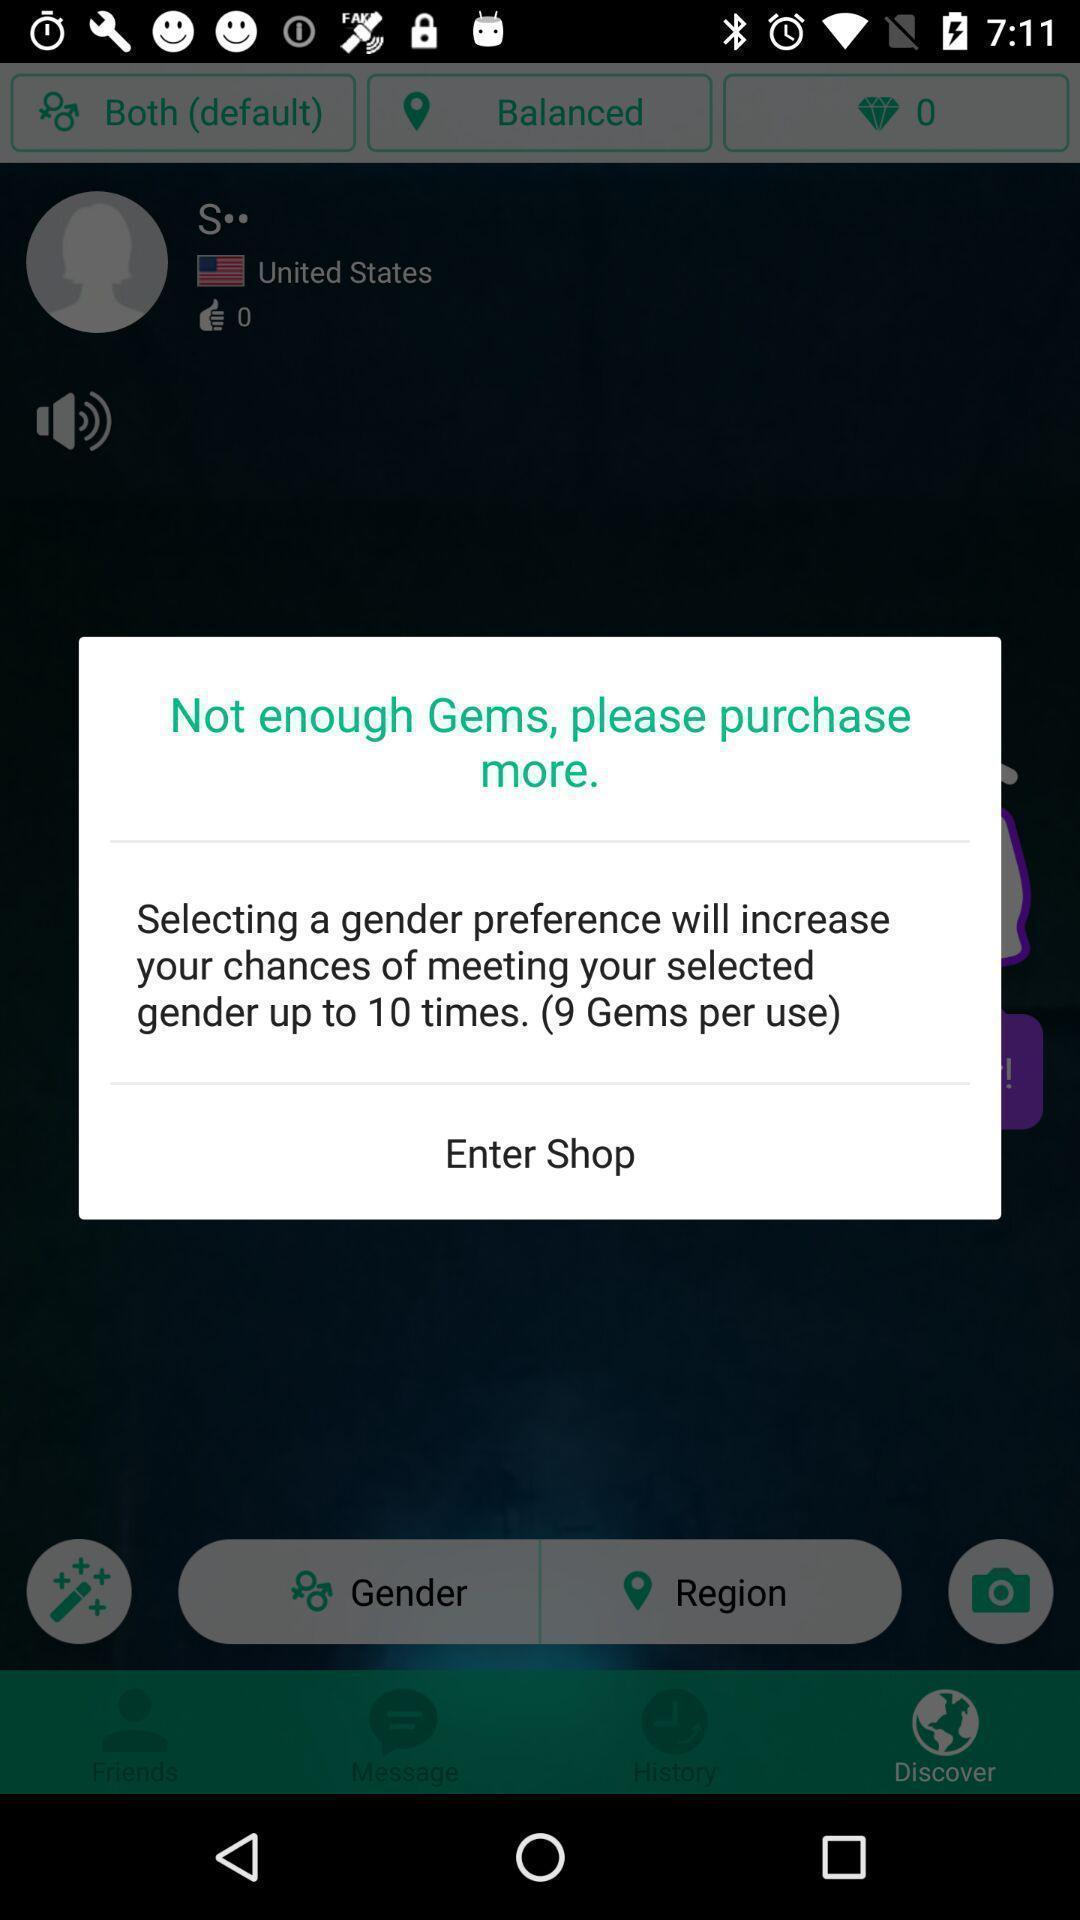Give me a narrative description of this picture. Pop-up for selecting gender preference to increase your chances. 